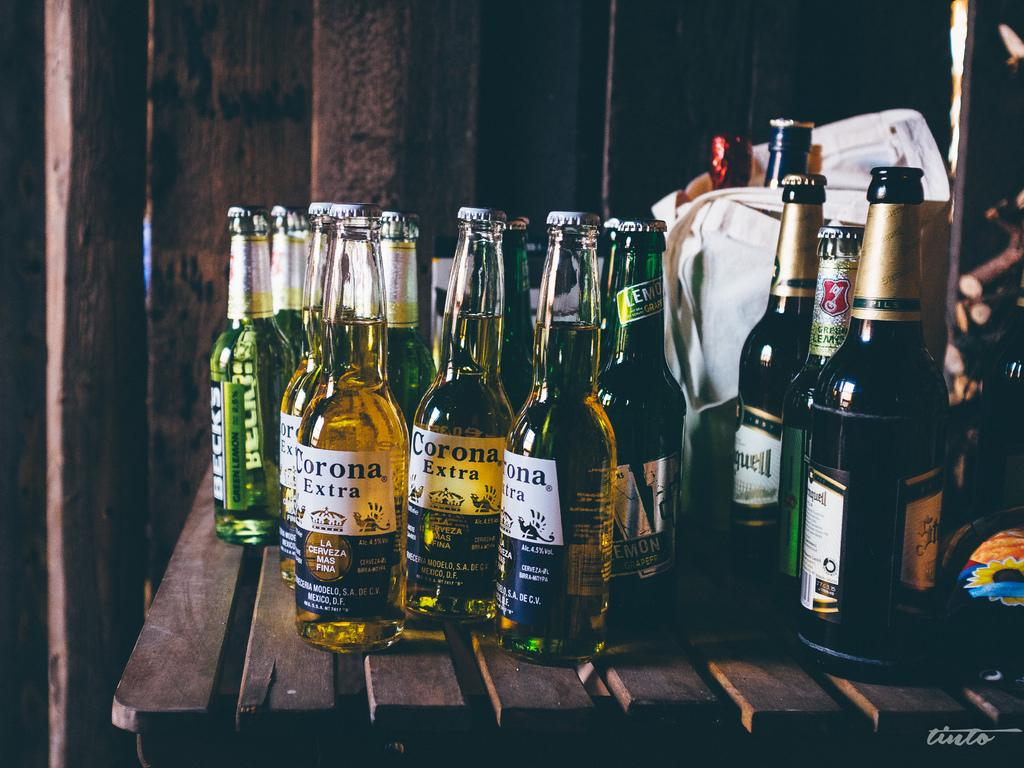What types of containers can be seen in the image? There are two different types of bottles in the image. What else is present in the image besides the bottles? There is a bag in the image. What is the relationship between the bottles and the bag? The bottles are inside the bag. How many pies are being carried in the bag in the image? There are no pies present in the image; it only contains bottles. 